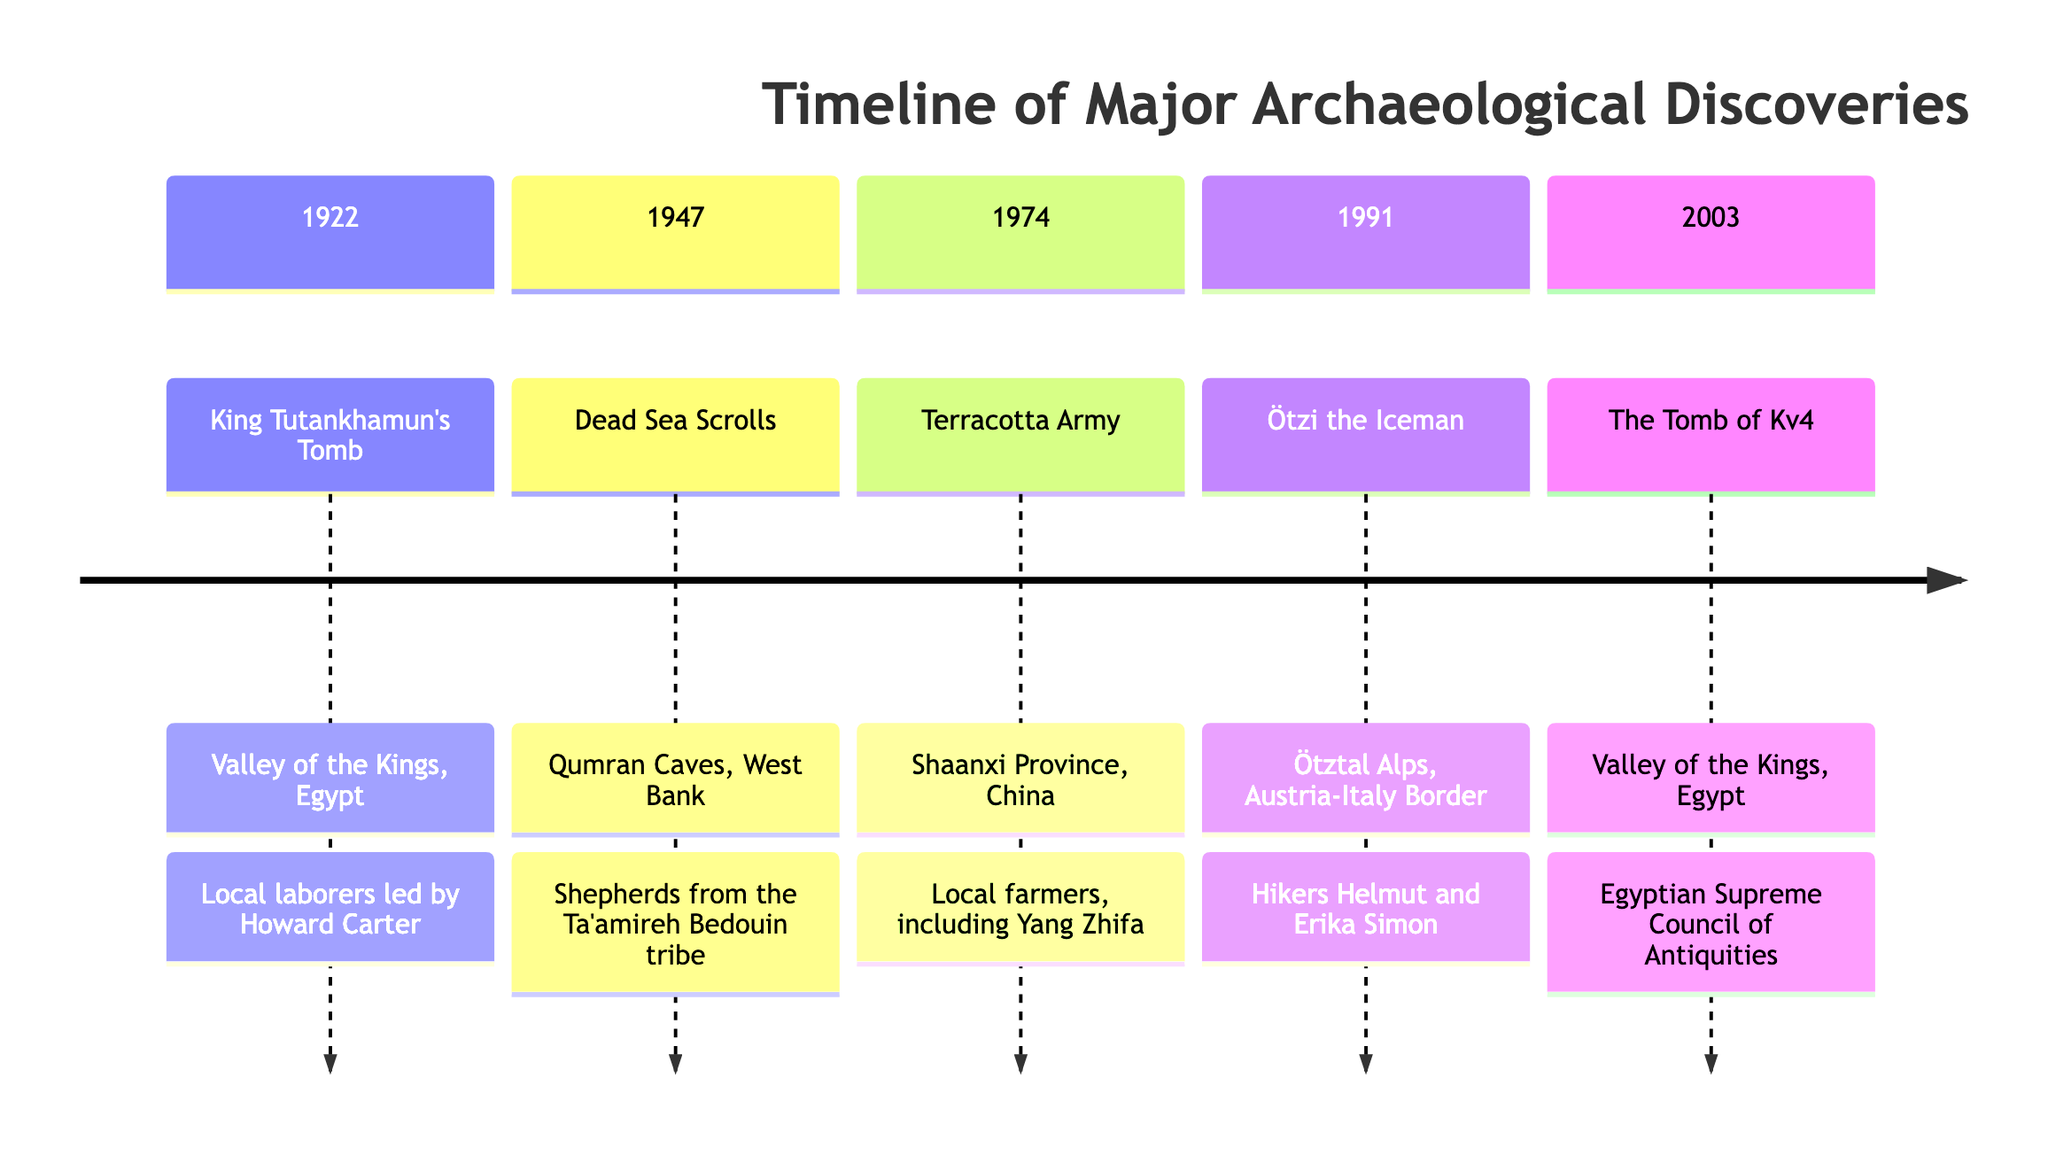What's the first major archaeological discovery listed on the timeline? The timeline begins with the discovery of King Tutankhamun's Tomb in 1922.
Answer: King Tutankhamun's Tomb How many major discoveries are presented in the timeline? The timeline lists five major archaeological discoveries, each from a different year.
Answer: 5 In which year was the Dead Sea Scrolls discovered? According to the timeline, the Dead Sea Scrolls were discovered in 1947.
Answer: 1947 Which discovery involved local farmers? The Terracotta Army discovery involved local farmers, specifically Yang Zhifa.
Answer: Terracotta Army What is the common location of the first and last discoveries? Both the King Tutankhamun's Tomb and the Tomb of Kv4 were discovered in the Valley of the Kings, Egypt.
Answer: Valley of the Kings Which local community was involved in the discovery of Ötzi the Iceman? The hikers who discovered Ötzi, Helmut and Erika Simon, were engaged in the archaeological find.
Answer: Hikers Which discovery occurred in the Ötztal Alps? The discovery that took place in the Ötztal Alps is Ötzi the Iceman.
Answer: Ötzi the Iceman Who led the excavation of King Tutankhamun's Tomb? Howard Carter led the excavation of King Tutankhamun's Tomb in the Valley of the Kings.
Answer: Howard Carter What is the significant contribution of the Ta'amireh Bedouin tribe? The Ta'amireh Bedouin tribe shepherds discovered the Dead Sea Scrolls in 1947.
Answer: Shepherds from the Ta'amireh Bedouin tribe 